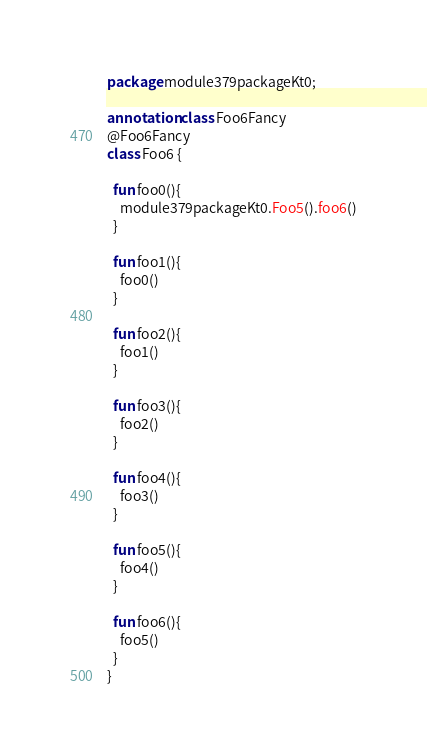Convert code to text. <code><loc_0><loc_0><loc_500><loc_500><_Kotlin_>package module379packageKt0;

annotation class Foo6Fancy
@Foo6Fancy
class Foo6 {

  fun foo0(){
    module379packageKt0.Foo5().foo6()
  }

  fun foo1(){
    foo0()
  }

  fun foo2(){
    foo1()
  }

  fun foo3(){
    foo2()
  }

  fun foo4(){
    foo3()
  }

  fun foo5(){
    foo4()
  }

  fun foo6(){
    foo5()
  }
}</code> 